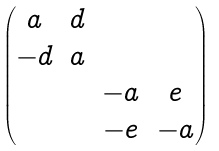Convert formula to latex. <formula><loc_0><loc_0><loc_500><loc_500>\begin{pmatrix} a & d & & \\ - d & a & & \\ & & - a & e \\ & & - e & - a \end{pmatrix}</formula> 